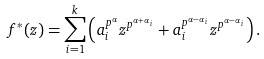Convert formula to latex. <formula><loc_0><loc_0><loc_500><loc_500>f ^ { * } ( z ) = \sum _ { i = 1 } ^ { k } \left ( a _ { i } ^ { p ^ { \alpha } } z ^ { p ^ { \alpha + \alpha _ { i } } } + a _ { i } ^ { p ^ { \alpha - \alpha _ { i } } } z ^ { p ^ { \alpha - \alpha _ { i } } } \right ) .</formula> 